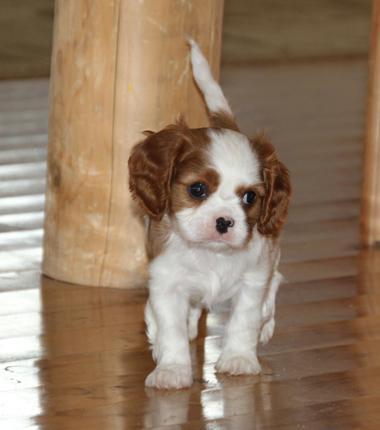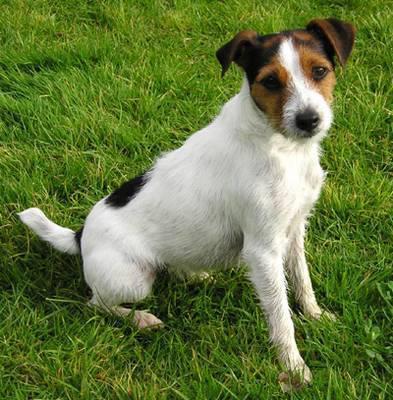The first image is the image on the left, the second image is the image on the right. Examine the images to the left and right. Is the description "At least one image has no grass." accurate? Answer yes or no. Yes. 